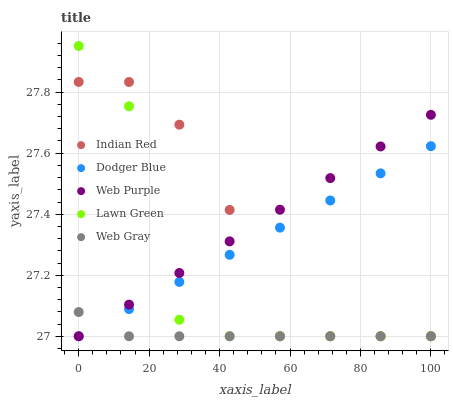Does Web Gray have the minimum area under the curve?
Answer yes or no. Yes. Does Web Purple have the maximum area under the curve?
Answer yes or no. Yes. Does Web Purple have the minimum area under the curve?
Answer yes or no. No. Does Web Gray have the maximum area under the curve?
Answer yes or no. No. Is Dodger Blue the smoothest?
Answer yes or no. Yes. Is Lawn Green the roughest?
Answer yes or no. Yes. Is Web Purple the smoothest?
Answer yes or no. No. Is Web Purple the roughest?
Answer yes or no. No. Does Lawn Green have the lowest value?
Answer yes or no. Yes. Does Lawn Green have the highest value?
Answer yes or no. Yes. Does Web Purple have the highest value?
Answer yes or no. No. Does Web Purple intersect Web Gray?
Answer yes or no. Yes. Is Web Purple less than Web Gray?
Answer yes or no. No. Is Web Purple greater than Web Gray?
Answer yes or no. No. 